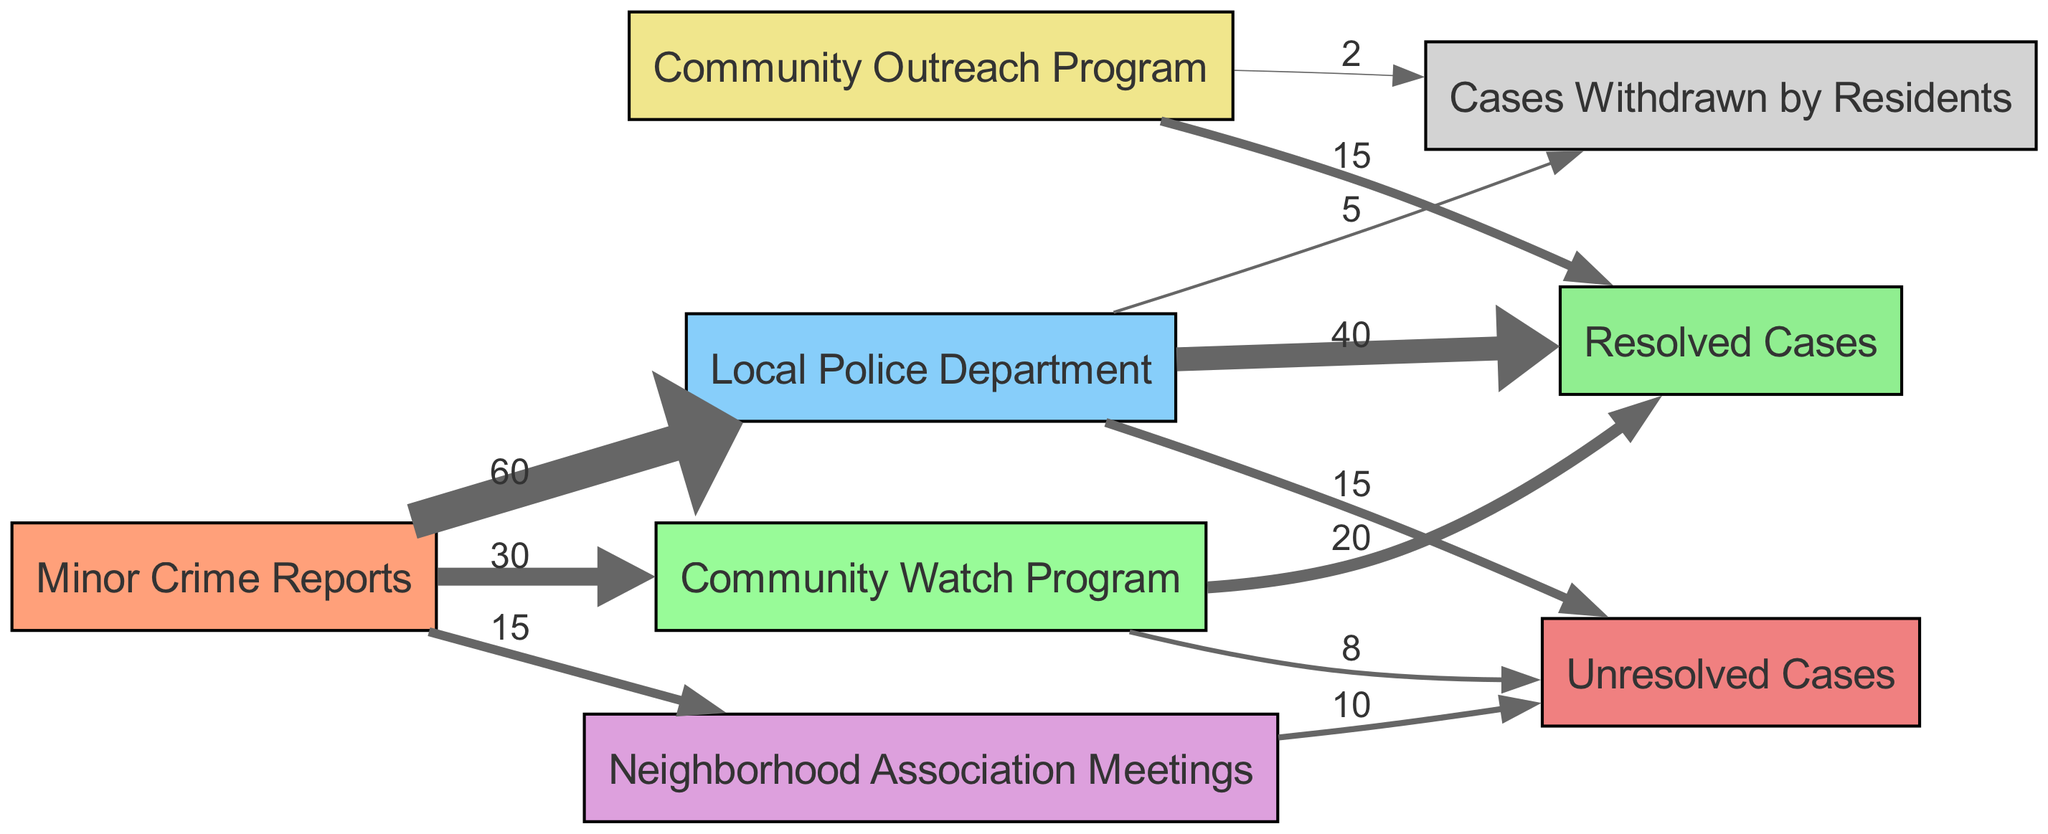What is the total number of minor crime reports? The total number of minor crime reports can be calculated by summing the values linked to "Minor Crime Reports." These values are 60 (Local Police Department), 30 (Community Watch Program), 15 (Neighborhood Association Meetings), leading to a total of 60 + 30 + 15 = 105 reports.
Answer: 105 How many cases were resolved by the Local Police Department? To find out how many cases were resolved by the Local Police Department, we look at the link from "Local Police Department" to "Resolved Cases," which has a value of 40.
Answer: 40 What resource had the highest flow of minor crime reports? The "Local Police Department" received the highest flow of minor crime reports, with a value of 60, compared to the Community Watch Program (30) and Neighborhood Association Meetings (15).
Answer: Local Police Department What is the total number of unresolved cases across all resources? The total number of unresolved cases can be found by summing the values of unresolved cases from all resources. This includes 15 (Local Police Department), 8 (Community Watch Program), and 10 (Neighborhood Association Meetings), totaling 15 + 8 + 10 = 33 unresolved cases.
Answer: 33 Which community resource contributed the least to cases resolved? The "Community Outreach Program" contributed the least to resolved cases, with a value of 15, which is lower than the contributions from the Local Police Department (40) and the Community Watch Program (20).
Answer: Community Outreach Program What percentage of the criminal reports led to cases withdrawn by residents? To find the percentage of reports that led to cases withdrawn by residents, we first find the total number of reports (105) and the number of cases withdrawn (5). The percentage can be calculated as (5 / 105) * 100 = 4.76%.
Answer: 4.76% How many minor crime reports were addressed through Neighborhood Association Meetings? The number of minor crime reports addressed through Neighborhood Association Meetings is given as 15, which comes directly from the link to that resource.
Answer: 15 Which resource had the highest number of unresolved cases? To determine which resource had the highest number of unresolved cases, we look at the unresolved cases from each resource: 15 (Local Police Department), 8 (Community Watch Program), and 10 (Neighborhood Association Meetings). The Local Police Department has the highest with 15 unresolved cases.
Answer: Local Police Department 